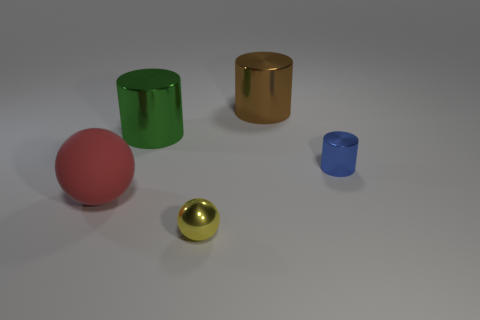There is a small object in front of the small blue cylinder; what number of tiny shiny balls are in front of it?
Offer a very short reply. 0. Are there any other things that are made of the same material as the red sphere?
Give a very brief answer. No. What is the material of the sphere that is left of the yellow thing on the right side of the big shiny cylinder that is in front of the brown shiny cylinder?
Offer a very short reply. Rubber. What material is the thing that is both to the right of the red matte thing and in front of the tiny blue cylinder?
Your answer should be very brief. Metal. What number of brown things have the same shape as the yellow metal object?
Give a very brief answer. 0. What size is the shiny thing in front of the tiny object behind the large red matte sphere?
Your response must be concise. Small. There is a big thing in front of the metallic cylinder in front of the big green shiny cylinder; what number of large green objects are on the left side of it?
Your answer should be compact. 0. What number of objects are both to the right of the red thing and to the left of the tiny blue shiny object?
Offer a very short reply. 3. Are there more yellow metal things on the right side of the matte object than small red shiny cylinders?
Make the answer very short. Yes. How many red spheres are the same size as the blue metal cylinder?
Give a very brief answer. 0. 